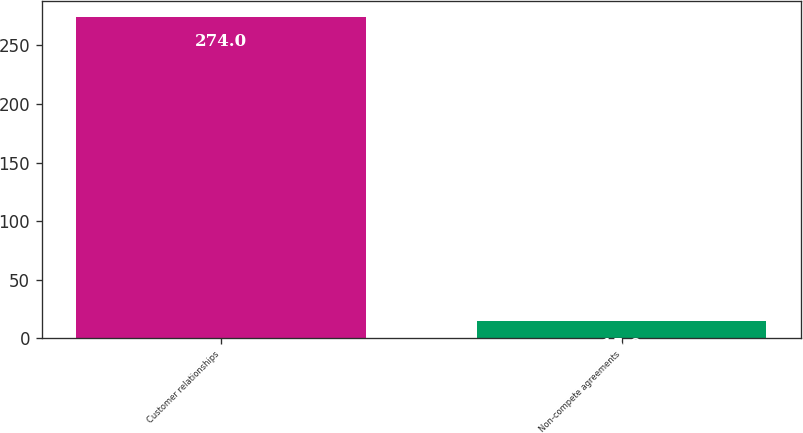Convert chart to OTSL. <chart><loc_0><loc_0><loc_500><loc_500><bar_chart><fcel>Customer relationships<fcel>Non-compete agreements<nl><fcel>274<fcel>15<nl></chart> 